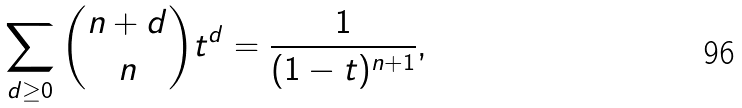Convert formula to latex. <formula><loc_0><loc_0><loc_500><loc_500>\sum _ { d \geq 0 } \binom { n + d } { n } t ^ { d } = \frac { 1 } { ( 1 - t ) ^ { n + 1 } } ,</formula> 